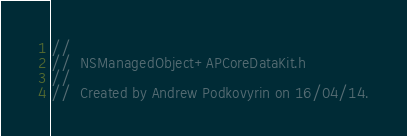<code> <loc_0><loc_0><loc_500><loc_500><_C_>//
//  NSManagedObject+APCoreDataKit.h
//
//  Created by Andrew Podkovyrin on 16/04/14.</code> 